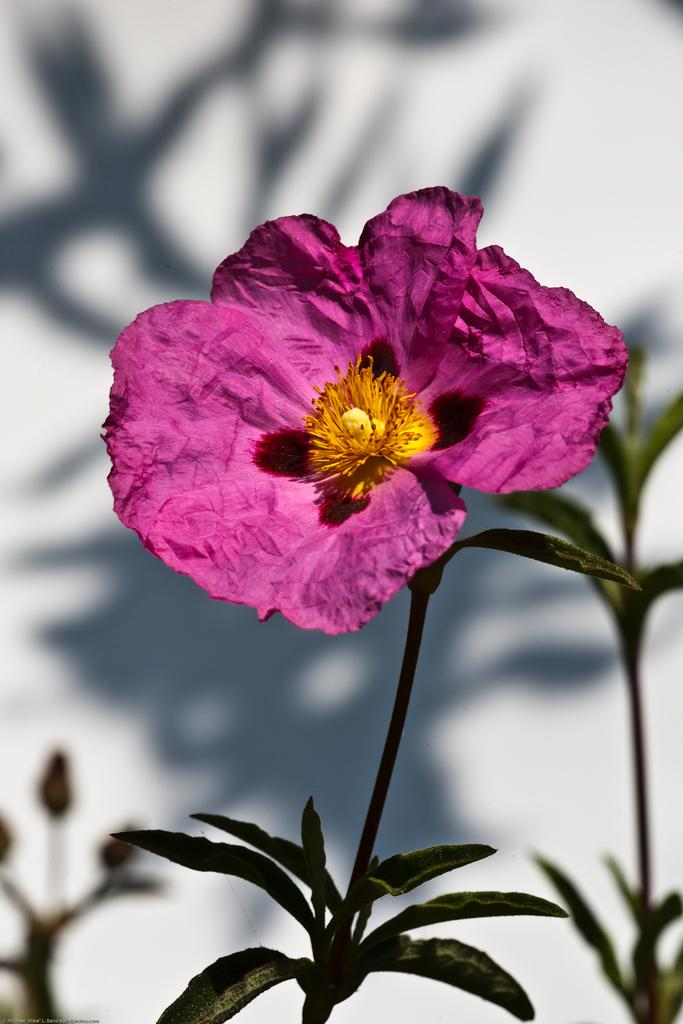What is the main subject of the image? The main subject of the image is a flower. Can you describe the flower's structure? The flower has a stem and leaves. What can be observed about the background of the image? The background of the image is blurry. What type of calculator is being used to measure the angle of the flower in the image? There is no calculator or angle measurement visible in the image. What type of game is being played with the flower in the image? There is no game being played with the flower in the image. 